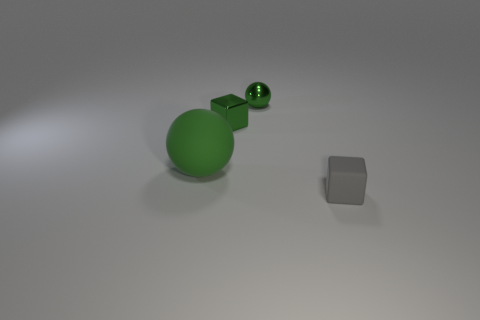The shiny ball has what color?
Provide a succinct answer. Green. There is a green metal block; are there any gray cubes to the left of it?
Give a very brief answer. No. There is a gray object; does it have the same shape as the matte thing to the left of the tiny rubber thing?
Your answer should be compact. No. How many other things are there of the same material as the big object?
Your answer should be compact. 1. There is a small cube that is on the left side of the block that is in front of the green metal cube that is left of the small shiny sphere; what is its color?
Provide a short and direct response. Green. The rubber object left of the green metal object on the right side of the green block is what shape?
Provide a short and direct response. Sphere. Are there more large green matte spheres on the right side of the tiny rubber thing than metallic blocks?
Make the answer very short. No. Does the rubber object that is behind the tiny gray object have the same shape as the small gray rubber object?
Keep it short and to the point. No. Is there a small brown shiny object of the same shape as the big matte thing?
Keep it short and to the point. No. What number of things are matte things to the left of the tiny gray rubber thing or large blue rubber spheres?
Your response must be concise. 1. 